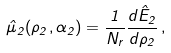<formula> <loc_0><loc_0><loc_500><loc_500>\hat { \mu } _ { 2 } ( \rho _ { 2 } , \alpha _ { 2 } ) = \frac { 1 } { N _ { r } } \frac { d \hat { E } _ { 2 } } { d \rho _ { 2 } } \, ,</formula> 